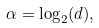<formula> <loc_0><loc_0><loc_500><loc_500>\alpha = \log _ { 2 } ( d ) ,</formula> 